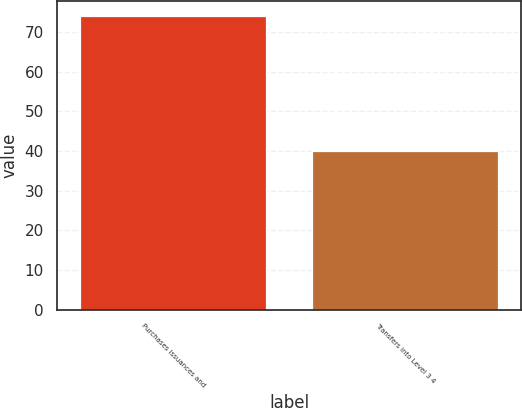<chart> <loc_0><loc_0><loc_500><loc_500><bar_chart><fcel>Purchases issuances and<fcel>Transfers into Level 3 4<nl><fcel>74<fcel>40<nl></chart> 